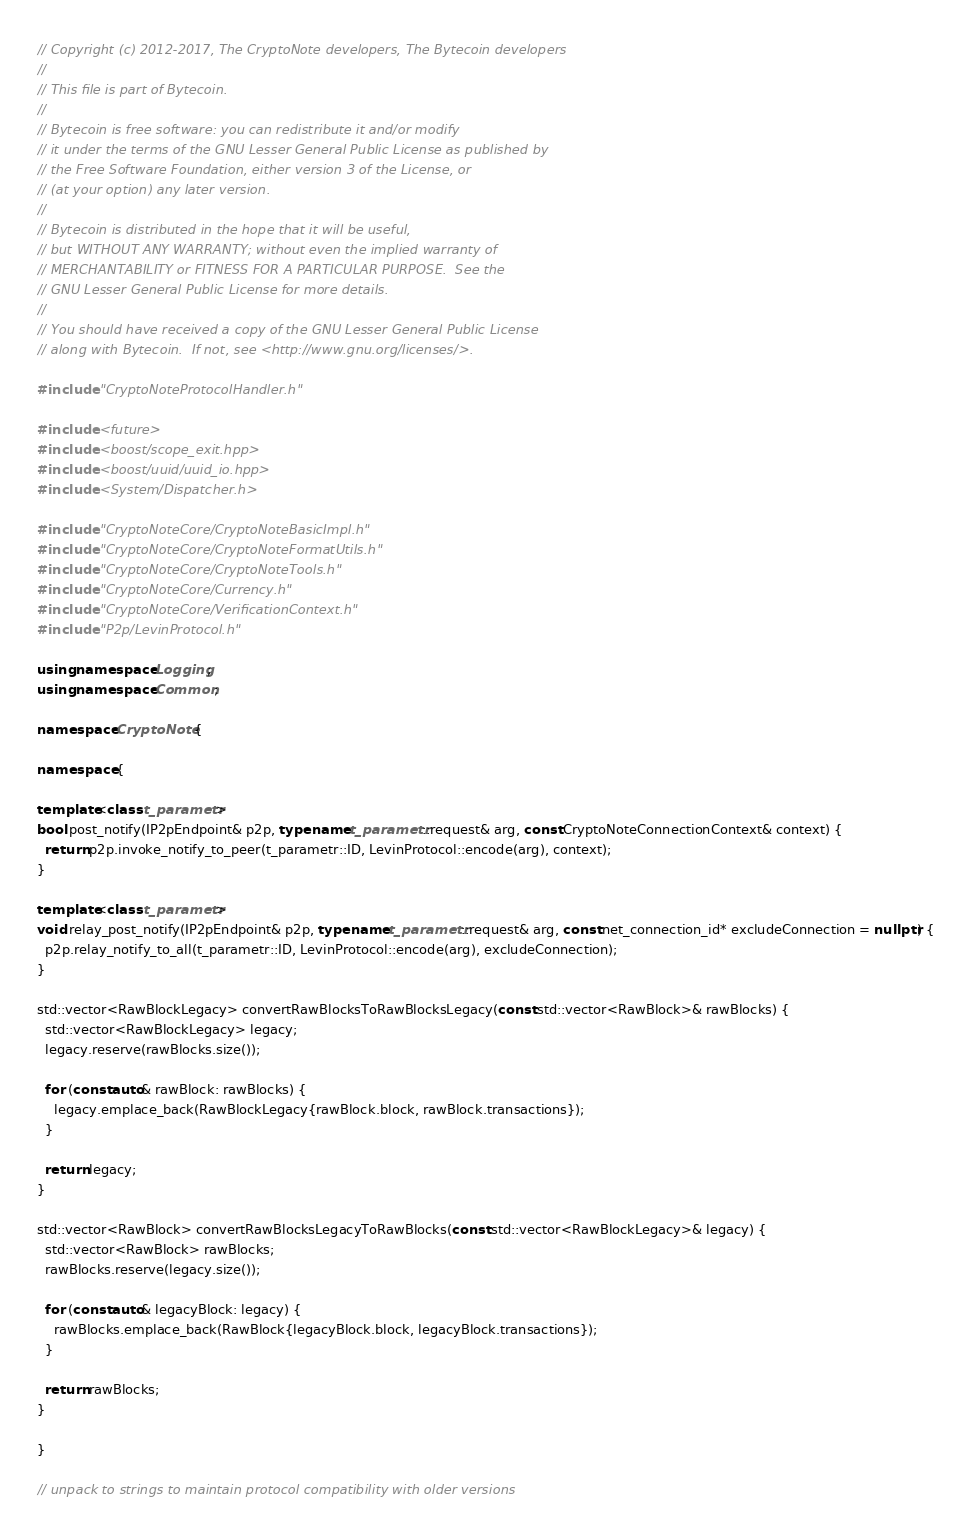Convert code to text. <code><loc_0><loc_0><loc_500><loc_500><_C++_>// Copyright (c) 2012-2017, The CryptoNote developers, The Bytecoin developers
//
// This file is part of Bytecoin.
//
// Bytecoin is free software: you can redistribute it and/or modify
// it under the terms of the GNU Lesser General Public License as published by
// the Free Software Foundation, either version 3 of the License, or
// (at your option) any later version.
//
// Bytecoin is distributed in the hope that it will be useful,
// but WITHOUT ANY WARRANTY; without even the implied warranty of
// MERCHANTABILITY or FITNESS FOR A PARTICULAR PURPOSE.  See the
// GNU Lesser General Public License for more details.
//
// You should have received a copy of the GNU Lesser General Public License
// along with Bytecoin.  If not, see <http://www.gnu.org/licenses/>.

#include "CryptoNoteProtocolHandler.h"

#include <future>
#include <boost/scope_exit.hpp>
#include <boost/uuid/uuid_io.hpp>
#include <System/Dispatcher.h>

#include "CryptoNoteCore/CryptoNoteBasicImpl.h"
#include "CryptoNoteCore/CryptoNoteFormatUtils.h"
#include "CryptoNoteCore/CryptoNoteTools.h"
#include "CryptoNoteCore/Currency.h"
#include "CryptoNoteCore/VerificationContext.h"
#include "P2p/LevinProtocol.h"

using namespace Logging;
using namespace Common;

namespace CryptoNote {

namespace {

template<class t_parametr>
bool post_notify(IP2pEndpoint& p2p, typename t_parametr::request& arg, const CryptoNoteConnectionContext& context) {
  return p2p.invoke_notify_to_peer(t_parametr::ID, LevinProtocol::encode(arg), context);
}

template<class t_parametr>
void relay_post_notify(IP2pEndpoint& p2p, typename t_parametr::request& arg, const net_connection_id* excludeConnection = nullptr) {
  p2p.relay_notify_to_all(t_parametr::ID, LevinProtocol::encode(arg), excludeConnection);
}

std::vector<RawBlockLegacy> convertRawBlocksToRawBlocksLegacy(const std::vector<RawBlock>& rawBlocks) {
  std::vector<RawBlockLegacy> legacy;
  legacy.reserve(rawBlocks.size());

  for (const auto& rawBlock: rawBlocks) {
    legacy.emplace_back(RawBlockLegacy{rawBlock.block, rawBlock.transactions});
  }

  return legacy;
}

std::vector<RawBlock> convertRawBlocksLegacyToRawBlocks(const std::vector<RawBlockLegacy>& legacy) {
  std::vector<RawBlock> rawBlocks;
  rawBlocks.reserve(legacy.size());

  for (const auto& legacyBlock: legacy) {
    rawBlocks.emplace_back(RawBlock{legacyBlock.block, legacyBlock.transactions});
  }

  return rawBlocks;
}

}

// unpack to strings to maintain protocol compatibility with older versions</code> 